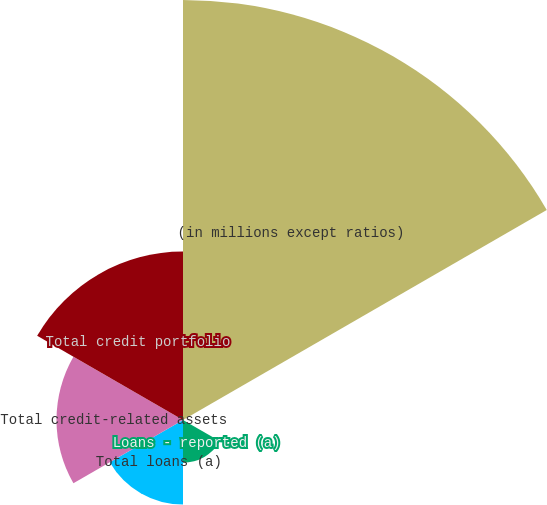Convert chart to OTSL. <chart><loc_0><loc_0><loc_500><loc_500><pie_chart><fcel>(in millions except ratios)<fcel>Loans retained (a)<fcel>Loans - reported (a)<fcel>Total loans (a)<fcel>Total credit-related assets<fcel>Total credit portfolio<nl><fcel>49.83%<fcel>0.08%<fcel>5.06%<fcel>10.03%<fcel>15.01%<fcel>19.98%<nl></chart> 